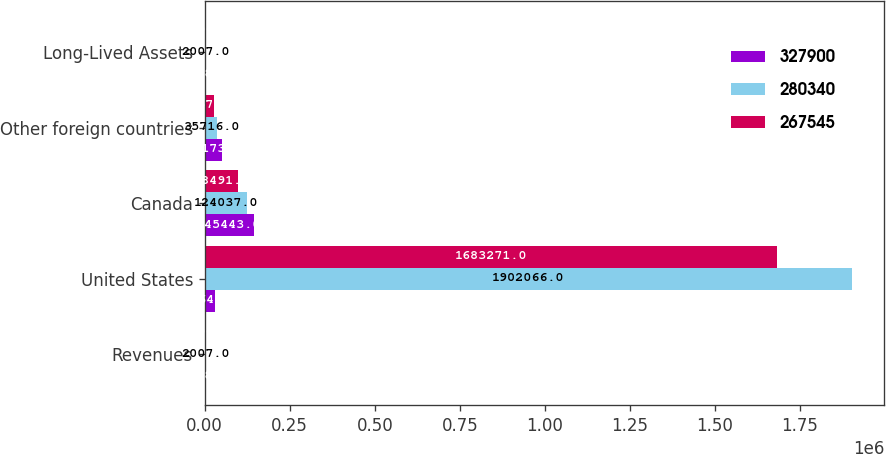Convert chart. <chart><loc_0><loc_0><loc_500><loc_500><stacked_bar_chart><ecel><fcel>Revenues<fcel>United States<fcel>Canada<fcel>Other foreign countries<fcel>Long-Lived Assets<nl><fcel>327900<fcel>2008<fcel>31645.5<fcel>145443<fcel>50173<fcel>2008<nl><fcel>280340<fcel>2007<fcel>1.90207e+06<fcel>124037<fcel>35716<fcel>2007<nl><fcel>267545<fcel>2006<fcel>1.68327e+06<fcel>98491<fcel>27575<fcel>2006<nl></chart> 